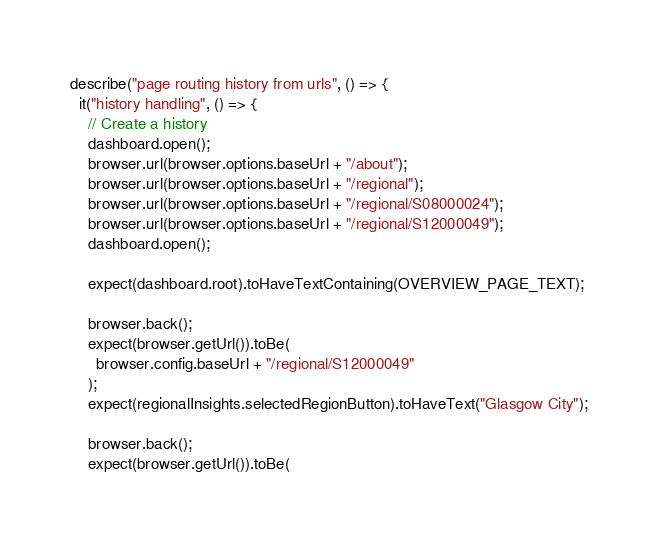Convert code to text. <code><loc_0><loc_0><loc_500><loc_500><_JavaScript_>describe("page routing history from urls", () => {
  it("history handling", () => {
    // Create a history
    dashboard.open();
    browser.url(browser.options.baseUrl + "/about");
    browser.url(browser.options.baseUrl + "/regional");
    browser.url(browser.options.baseUrl + "/regional/S08000024");
    browser.url(browser.options.baseUrl + "/regional/S12000049");
    dashboard.open();

    expect(dashboard.root).toHaveTextContaining(OVERVIEW_PAGE_TEXT);

    browser.back();
    expect(browser.getUrl()).toBe(
      browser.config.baseUrl + "/regional/S12000049"
    );
    expect(regionalInsights.selectedRegionButton).toHaveText("Glasgow City");

    browser.back();
    expect(browser.getUrl()).toBe(</code> 